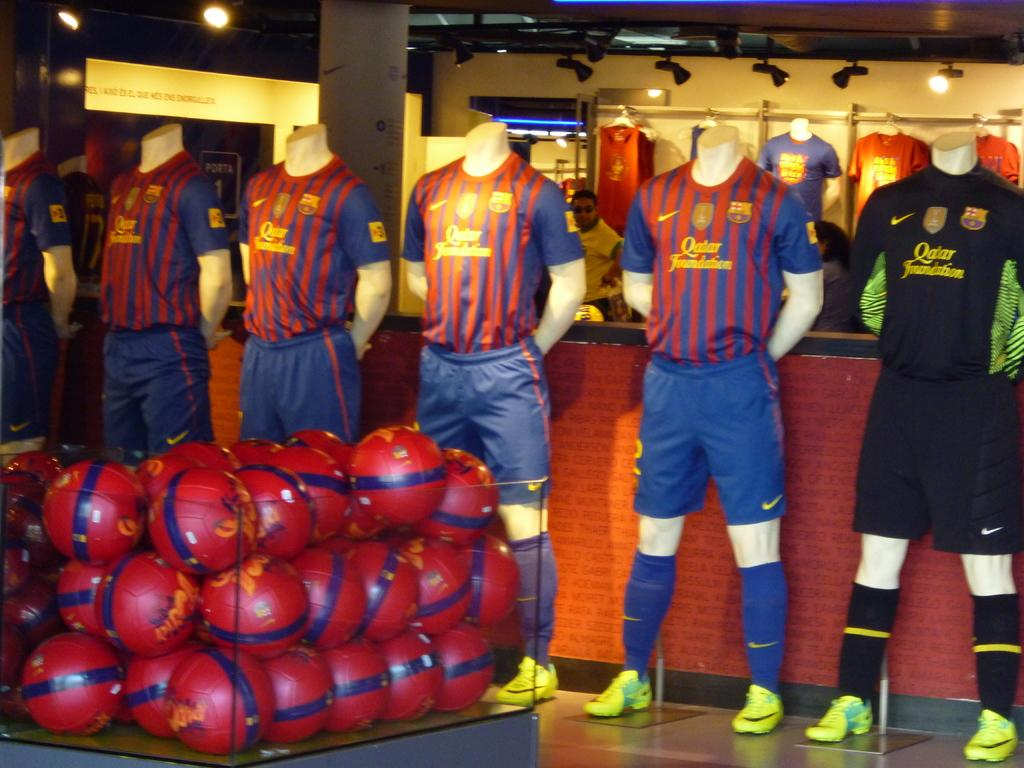<image>
Share a concise interpretation of the image provided. Striped shirts have a Qatar Foundation logo on them. 